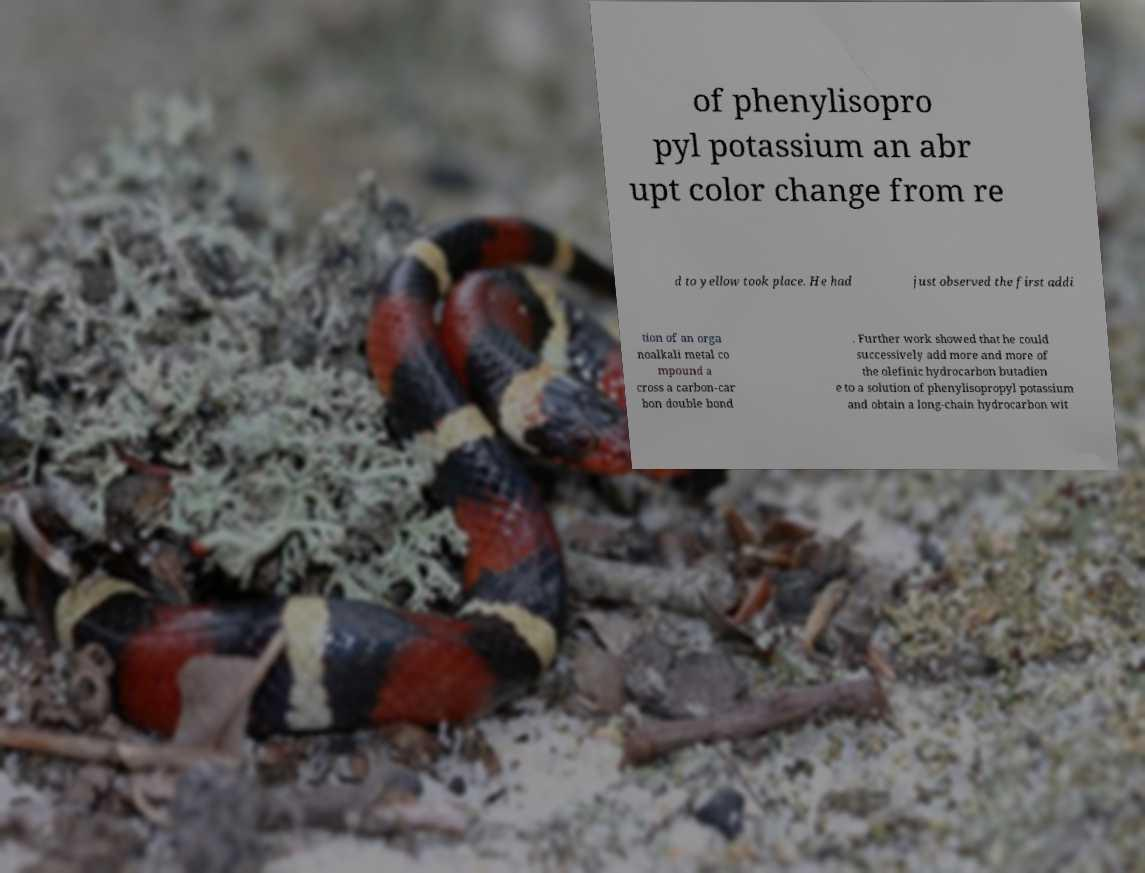Please identify and transcribe the text found in this image. of phenylisopro pyl potassium an abr upt color change from re d to yellow took place. He had just observed the first addi tion of an orga noalkali metal co mpound a cross a carbon-car bon double bond . Further work showed that he could successively add more and more of the olefinic hydrocarbon butadien e to a solution of phenylisopropyl potassium and obtain a long-chain hydrocarbon wit 